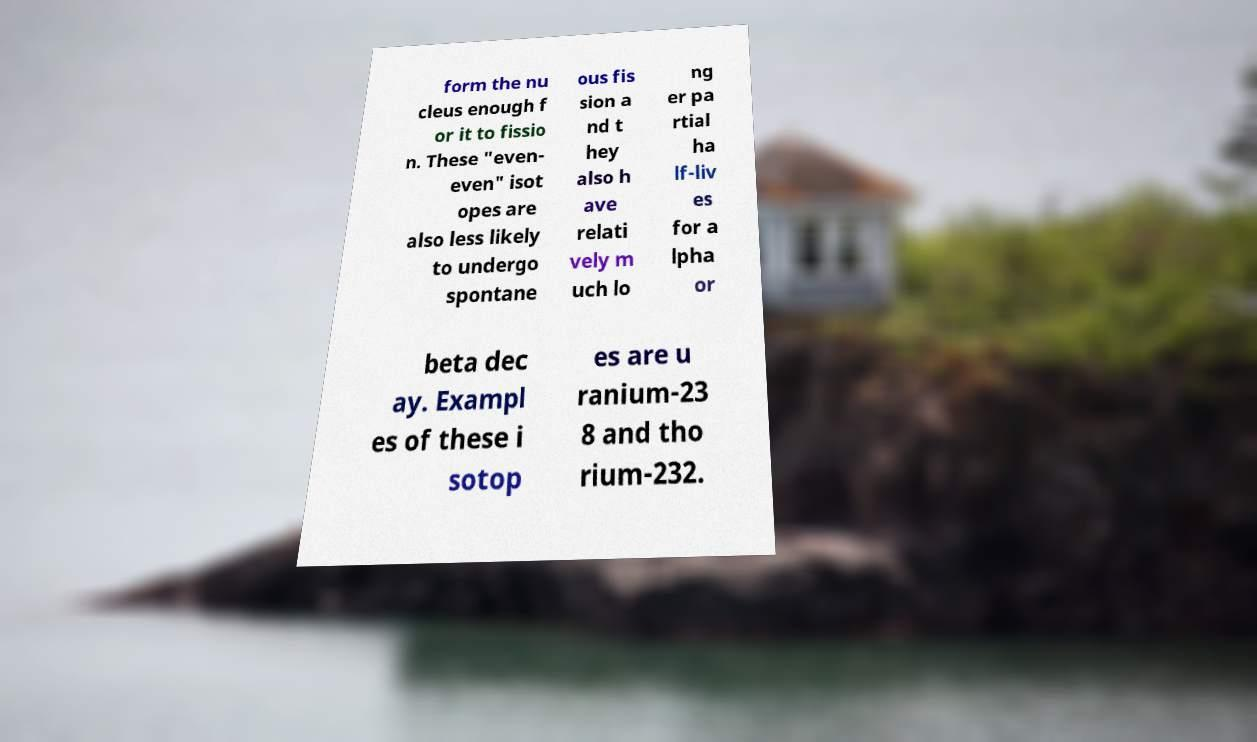Please read and relay the text visible in this image. What does it say? form the nu cleus enough f or it to fissio n. These "even- even" isot opes are also less likely to undergo spontane ous fis sion a nd t hey also h ave relati vely m uch lo ng er pa rtial ha lf-liv es for a lpha or beta dec ay. Exampl es of these i sotop es are u ranium-23 8 and tho rium-232. 